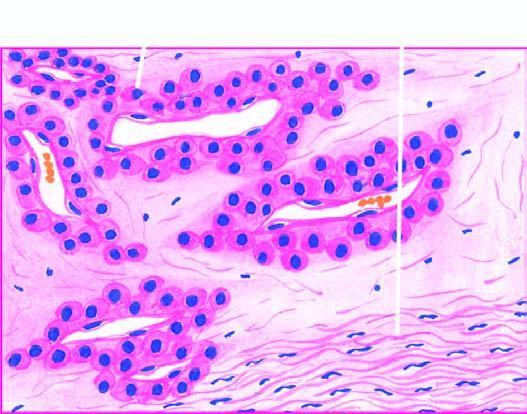what are there lined by endothelial cells and surrounded by nests and masses of glomus cells?
Answer the question using a single word or phrase. Blood-filled vascular channels 